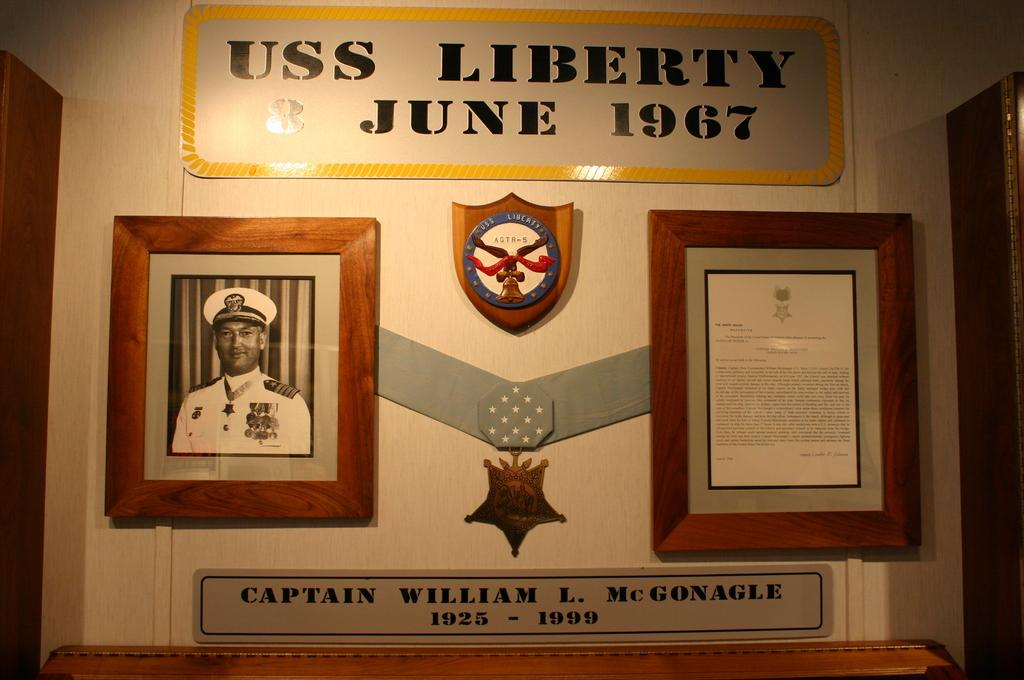<image>
Give a short and clear explanation of the subsequent image. A plaque with a medal attached to it is dated June 1967. 